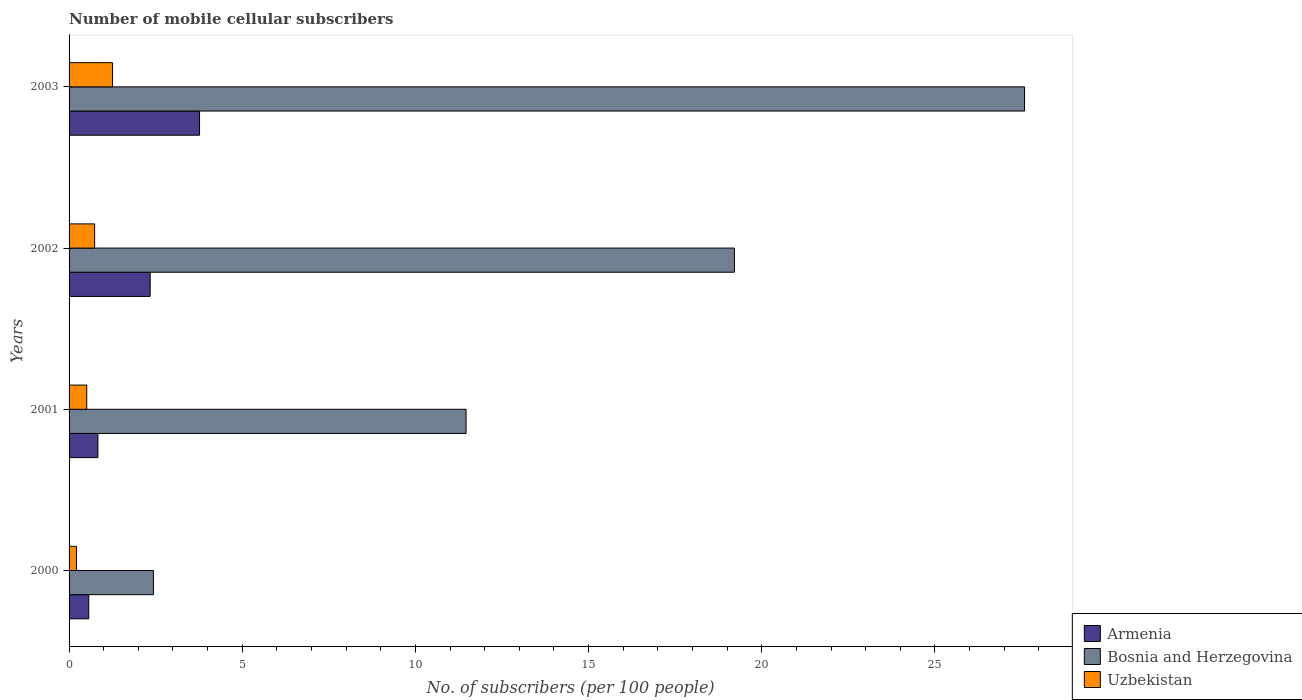How many different coloured bars are there?
Offer a terse response. 3. Are the number of bars per tick equal to the number of legend labels?
Provide a short and direct response. Yes. Are the number of bars on each tick of the Y-axis equal?
Your answer should be very brief. Yes. How many bars are there on the 3rd tick from the bottom?
Your answer should be compact. 3. In how many cases, is the number of bars for a given year not equal to the number of legend labels?
Make the answer very short. 0. What is the number of mobile cellular subscribers in Bosnia and Herzegovina in 2001?
Offer a terse response. 11.46. Across all years, what is the maximum number of mobile cellular subscribers in Bosnia and Herzegovina?
Provide a short and direct response. 27.59. Across all years, what is the minimum number of mobile cellular subscribers in Uzbekistan?
Offer a very short reply. 0.21. What is the total number of mobile cellular subscribers in Armenia in the graph?
Provide a succinct answer. 7.51. What is the difference between the number of mobile cellular subscribers in Uzbekistan in 2000 and that in 2003?
Offer a terse response. -1.04. What is the difference between the number of mobile cellular subscribers in Armenia in 2000 and the number of mobile cellular subscribers in Bosnia and Herzegovina in 2002?
Your answer should be compact. -18.64. What is the average number of mobile cellular subscribers in Uzbekistan per year?
Offer a terse response. 0.68. In the year 2001, what is the difference between the number of mobile cellular subscribers in Uzbekistan and number of mobile cellular subscribers in Bosnia and Herzegovina?
Offer a very short reply. -10.95. What is the ratio of the number of mobile cellular subscribers in Bosnia and Herzegovina in 2000 to that in 2003?
Ensure brevity in your answer.  0.09. Is the difference between the number of mobile cellular subscribers in Uzbekistan in 2000 and 2001 greater than the difference between the number of mobile cellular subscribers in Bosnia and Herzegovina in 2000 and 2001?
Keep it short and to the point. Yes. What is the difference between the highest and the second highest number of mobile cellular subscribers in Uzbekistan?
Offer a very short reply. 0.52. What is the difference between the highest and the lowest number of mobile cellular subscribers in Armenia?
Provide a short and direct response. 3.2. In how many years, is the number of mobile cellular subscribers in Armenia greater than the average number of mobile cellular subscribers in Armenia taken over all years?
Your response must be concise. 2. Is the sum of the number of mobile cellular subscribers in Uzbekistan in 2002 and 2003 greater than the maximum number of mobile cellular subscribers in Bosnia and Herzegovina across all years?
Offer a very short reply. No. What does the 1st bar from the top in 2000 represents?
Make the answer very short. Uzbekistan. What does the 1st bar from the bottom in 2003 represents?
Give a very brief answer. Armenia. What is the difference between two consecutive major ticks on the X-axis?
Make the answer very short. 5. Are the values on the major ticks of X-axis written in scientific E-notation?
Give a very brief answer. No. Does the graph contain any zero values?
Your response must be concise. No. How are the legend labels stacked?
Offer a terse response. Vertical. What is the title of the graph?
Provide a succinct answer. Number of mobile cellular subscribers. What is the label or title of the X-axis?
Offer a terse response. No. of subscribers (per 100 people). What is the label or title of the Y-axis?
Give a very brief answer. Years. What is the No. of subscribers (per 100 people) in Armenia in 2000?
Your answer should be very brief. 0.57. What is the No. of subscribers (per 100 people) in Bosnia and Herzegovina in 2000?
Offer a terse response. 2.44. What is the No. of subscribers (per 100 people) in Uzbekistan in 2000?
Your answer should be compact. 0.21. What is the No. of subscribers (per 100 people) in Armenia in 2001?
Ensure brevity in your answer.  0.83. What is the No. of subscribers (per 100 people) in Bosnia and Herzegovina in 2001?
Your answer should be compact. 11.46. What is the No. of subscribers (per 100 people) of Uzbekistan in 2001?
Give a very brief answer. 0.51. What is the No. of subscribers (per 100 people) in Armenia in 2002?
Ensure brevity in your answer.  2.34. What is the No. of subscribers (per 100 people) in Bosnia and Herzegovina in 2002?
Give a very brief answer. 19.21. What is the No. of subscribers (per 100 people) of Uzbekistan in 2002?
Give a very brief answer. 0.74. What is the No. of subscribers (per 100 people) in Armenia in 2003?
Your answer should be compact. 3.77. What is the No. of subscribers (per 100 people) of Bosnia and Herzegovina in 2003?
Ensure brevity in your answer.  27.59. What is the No. of subscribers (per 100 people) in Uzbekistan in 2003?
Provide a succinct answer. 1.26. Across all years, what is the maximum No. of subscribers (per 100 people) in Armenia?
Keep it short and to the point. 3.77. Across all years, what is the maximum No. of subscribers (per 100 people) in Bosnia and Herzegovina?
Keep it short and to the point. 27.59. Across all years, what is the maximum No. of subscribers (per 100 people) in Uzbekistan?
Ensure brevity in your answer.  1.26. Across all years, what is the minimum No. of subscribers (per 100 people) of Armenia?
Offer a very short reply. 0.57. Across all years, what is the minimum No. of subscribers (per 100 people) in Bosnia and Herzegovina?
Provide a succinct answer. 2.44. Across all years, what is the minimum No. of subscribers (per 100 people) of Uzbekistan?
Your response must be concise. 0.21. What is the total No. of subscribers (per 100 people) of Armenia in the graph?
Offer a terse response. 7.51. What is the total No. of subscribers (per 100 people) of Bosnia and Herzegovina in the graph?
Make the answer very short. 60.7. What is the total No. of subscribers (per 100 people) of Uzbekistan in the graph?
Make the answer very short. 2.72. What is the difference between the No. of subscribers (per 100 people) of Armenia in 2000 and that in 2001?
Give a very brief answer. -0.27. What is the difference between the No. of subscribers (per 100 people) of Bosnia and Herzegovina in 2000 and that in 2001?
Your answer should be compact. -9.03. What is the difference between the No. of subscribers (per 100 people) of Uzbekistan in 2000 and that in 2001?
Provide a short and direct response. -0.3. What is the difference between the No. of subscribers (per 100 people) of Armenia in 2000 and that in 2002?
Offer a terse response. -1.77. What is the difference between the No. of subscribers (per 100 people) of Bosnia and Herzegovina in 2000 and that in 2002?
Offer a terse response. -16.78. What is the difference between the No. of subscribers (per 100 people) of Uzbekistan in 2000 and that in 2002?
Keep it short and to the point. -0.52. What is the difference between the No. of subscribers (per 100 people) in Armenia in 2000 and that in 2003?
Your answer should be compact. -3.2. What is the difference between the No. of subscribers (per 100 people) of Bosnia and Herzegovina in 2000 and that in 2003?
Offer a terse response. -25.15. What is the difference between the No. of subscribers (per 100 people) in Uzbekistan in 2000 and that in 2003?
Your response must be concise. -1.04. What is the difference between the No. of subscribers (per 100 people) in Armenia in 2001 and that in 2002?
Your answer should be very brief. -1.51. What is the difference between the No. of subscribers (per 100 people) of Bosnia and Herzegovina in 2001 and that in 2002?
Offer a very short reply. -7.75. What is the difference between the No. of subscribers (per 100 people) of Uzbekistan in 2001 and that in 2002?
Keep it short and to the point. -0.23. What is the difference between the No. of subscribers (per 100 people) in Armenia in 2001 and that in 2003?
Your response must be concise. -2.93. What is the difference between the No. of subscribers (per 100 people) of Bosnia and Herzegovina in 2001 and that in 2003?
Ensure brevity in your answer.  -16.12. What is the difference between the No. of subscribers (per 100 people) of Uzbekistan in 2001 and that in 2003?
Ensure brevity in your answer.  -0.75. What is the difference between the No. of subscribers (per 100 people) of Armenia in 2002 and that in 2003?
Your response must be concise. -1.43. What is the difference between the No. of subscribers (per 100 people) of Bosnia and Herzegovina in 2002 and that in 2003?
Your answer should be very brief. -8.38. What is the difference between the No. of subscribers (per 100 people) of Uzbekistan in 2002 and that in 2003?
Give a very brief answer. -0.52. What is the difference between the No. of subscribers (per 100 people) of Armenia in 2000 and the No. of subscribers (per 100 people) of Bosnia and Herzegovina in 2001?
Offer a very short reply. -10.9. What is the difference between the No. of subscribers (per 100 people) in Armenia in 2000 and the No. of subscribers (per 100 people) in Uzbekistan in 2001?
Your answer should be compact. 0.06. What is the difference between the No. of subscribers (per 100 people) in Bosnia and Herzegovina in 2000 and the No. of subscribers (per 100 people) in Uzbekistan in 2001?
Provide a short and direct response. 1.93. What is the difference between the No. of subscribers (per 100 people) in Armenia in 2000 and the No. of subscribers (per 100 people) in Bosnia and Herzegovina in 2002?
Provide a short and direct response. -18.64. What is the difference between the No. of subscribers (per 100 people) in Armenia in 2000 and the No. of subscribers (per 100 people) in Uzbekistan in 2002?
Give a very brief answer. -0.17. What is the difference between the No. of subscribers (per 100 people) of Bosnia and Herzegovina in 2000 and the No. of subscribers (per 100 people) of Uzbekistan in 2002?
Your answer should be compact. 1.7. What is the difference between the No. of subscribers (per 100 people) of Armenia in 2000 and the No. of subscribers (per 100 people) of Bosnia and Herzegovina in 2003?
Your answer should be very brief. -27.02. What is the difference between the No. of subscribers (per 100 people) of Armenia in 2000 and the No. of subscribers (per 100 people) of Uzbekistan in 2003?
Your answer should be very brief. -0.69. What is the difference between the No. of subscribers (per 100 people) in Bosnia and Herzegovina in 2000 and the No. of subscribers (per 100 people) in Uzbekistan in 2003?
Provide a succinct answer. 1.18. What is the difference between the No. of subscribers (per 100 people) in Armenia in 2001 and the No. of subscribers (per 100 people) in Bosnia and Herzegovina in 2002?
Keep it short and to the point. -18.38. What is the difference between the No. of subscribers (per 100 people) of Armenia in 2001 and the No. of subscribers (per 100 people) of Uzbekistan in 2002?
Offer a very short reply. 0.1. What is the difference between the No. of subscribers (per 100 people) of Bosnia and Herzegovina in 2001 and the No. of subscribers (per 100 people) of Uzbekistan in 2002?
Provide a succinct answer. 10.73. What is the difference between the No. of subscribers (per 100 people) in Armenia in 2001 and the No. of subscribers (per 100 people) in Bosnia and Herzegovina in 2003?
Give a very brief answer. -26.76. What is the difference between the No. of subscribers (per 100 people) in Armenia in 2001 and the No. of subscribers (per 100 people) in Uzbekistan in 2003?
Keep it short and to the point. -0.42. What is the difference between the No. of subscribers (per 100 people) of Bosnia and Herzegovina in 2001 and the No. of subscribers (per 100 people) of Uzbekistan in 2003?
Ensure brevity in your answer.  10.21. What is the difference between the No. of subscribers (per 100 people) of Armenia in 2002 and the No. of subscribers (per 100 people) of Bosnia and Herzegovina in 2003?
Ensure brevity in your answer.  -25.25. What is the difference between the No. of subscribers (per 100 people) in Armenia in 2002 and the No. of subscribers (per 100 people) in Uzbekistan in 2003?
Your response must be concise. 1.09. What is the difference between the No. of subscribers (per 100 people) of Bosnia and Herzegovina in 2002 and the No. of subscribers (per 100 people) of Uzbekistan in 2003?
Your answer should be compact. 17.96. What is the average No. of subscribers (per 100 people) in Armenia per year?
Your answer should be compact. 1.88. What is the average No. of subscribers (per 100 people) of Bosnia and Herzegovina per year?
Your answer should be very brief. 15.17. What is the average No. of subscribers (per 100 people) in Uzbekistan per year?
Offer a terse response. 0.68. In the year 2000, what is the difference between the No. of subscribers (per 100 people) of Armenia and No. of subscribers (per 100 people) of Bosnia and Herzegovina?
Ensure brevity in your answer.  -1.87. In the year 2000, what is the difference between the No. of subscribers (per 100 people) in Armenia and No. of subscribers (per 100 people) in Uzbekistan?
Ensure brevity in your answer.  0.35. In the year 2000, what is the difference between the No. of subscribers (per 100 people) in Bosnia and Herzegovina and No. of subscribers (per 100 people) in Uzbekistan?
Your answer should be very brief. 2.22. In the year 2001, what is the difference between the No. of subscribers (per 100 people) of Armenia and No. of subscribers (per 100 people) of Bosnia and Herzegovina?
Give a very brief answer. -10.63. In the year 2001, what is the difference between the No. of subscribers (per 100 people) in Armenia and No. of subscribers (per 100 people) in Uzbekistan?
Offer a very short reply. 0.32. In the year 2001, what is the difference between the No. of subscribers (per 100 people) in Bosnia and Herzegovina and No. of subscribers (per 100 people) in Uzbekistan?
Your answer should be compact. 10.95. In the year 2002, what is the difference between the No. of subscribers (per 100 people) in Armenia and No. of subscribers (per 100 people) in Bosnia and Herzegovina?
Make the answer very short. -16.87. In the year 2002, what is the difference between the No. of subscribers (per 100 people) of Armenia and No. of subscribers (per 100 people) of Uzbekistan?
Offer a very short reply. 1.6. In the year 2002, what is the difference between the No. of subscribers (per 100 people) in Bosnia and Herzegovina and No. of subscribers (per 100 people) in Uzbekistan?
Offer a very short reply. 18.47. In the year 2003, what is the difference between the No. of subscribers (per 100 people) of Armenia and No. of subscribers (per 100 people) of Bosnia and Herzegovina?
Offer a terse response. -23.82. In the year 2003, what is the difference between the No. of subscribers (per 100 people) in Armenia and No. of subscribers (per 100 people) in Uzbekistan?
Give a very brief answer. 2.51. In the year 2003, what is the difference between the No. of subscribers (per 100 people) of Bosnia and Herzegovina and No. of subscribers (per 100 people) of Uzbekistan?
Keep it short and to the point. 26.33. What is the ratio of the No. of subscribers (per 100 people) in Armenia in 2000 to that in 2001?
Offer a very short reply. 0.68. What is the ratio of the No. of subscribers (per 100 people) of Bosnia and Herzegovina in 2000 to that in 2001?
Ensure brevity in your answer.  0.21. What is the ratio of the No. of subscribers (per 100 people) of Uzbekistan in 2000 to that in 2001?
Offer a very short reply. 0.42. What is the ratio of the No. of subscribers (per 100 people) in Armenia in 2000 to that in 2002?
Ensure brevity in your answer.  0.24. What is the ratio of the No. of subscribers (per 100 people) of Bosnia and Herzegovina in 2000 to that in 2002?
Provide a succinct answer. 0.13. What is the ratio of the No. of subscribers (per 100 people) of Uzbekistan in 2000 to that in 2002?
Give a very brief answer. 0.29. What is the ratio of the No. of subscribers (per 100 people) in Armenia in 2000 to that in 2003?
Your answer should be very brief. 0.15. What is the ratio of the No. of subscribers (per 100 people) of Bosnia and Herzegovina in 2000 to that in 2003?
Offer a terse response. 0.09. What is the ratio of the No. of subscribers (per 100 people) in Uzbekistan in 2000 to that in 2003?
Make the answer very short. 0.17. What is the ratio of the No. of subscribers (per 100 people) of Armenia in 2001 to that in 2002?
Give a very brief answer. 0.36. What is the ratio of the No. of subscribers (per 100 people) of Bosnia and Herzegovina in 2001 to that in 2002?
Make the answer very short. 0.6. What is the ratio of the No. of subscribers (per 100 people) in Uzbekistan in 2001 to that in 2002?
Provide a succinct answer. 0.69. What is the ratio of the No. of subscribers (per 100 people) in Armenia in 2001 to that in 2003?
Your response must be concise. 0.22. What is the ratio of the No. of subscribers (per 100 people) of Bosnia and Herzegovina in 2001 to that in 2003?
Provide a short and direct response. 0.42. What is the ratio of the No. of subscribers (per 100 people) in Uzbekistan in 2001 to that in 2003?
Your answer should be very brief. 0.41. What is the ratio of the No. of subscribers (per 100 people) of Armenia in 2002 to that in 2003?
Provide a succinct answer. 0.62. What is the ratio of the No. of subscribers (per 100 people) in Bosnia and Herzegovina in 2002 to that in 2003?
Your answer should be compact. 0.7. What is the ratio of the No. of subscribers (per 100 people) in Uzbekistan in 2002 to that in 2003?
Provide a short and direct response. 0.59. What is the difference between the highest and the second highest No. of subscribers (per 100 people) in Armenia?
Keep it short and to the point. 1.43. What is the difference between the highest and the second highest No. of subscribers (per 100 people) of Bosnia and Herzegovina?
Ensure brevity in your answer.  8.38. What is the difference between the highest and the second highest No. of subscribers (per 100 people) in Uzbekistan?
Provide a succinct answer. 0.52. What is the difference between the highest and the lowest No. of subscribers (per 100 people) of Armenia?
Provide a short and direct response. 3.2. What is the difference between the highest and the lowest No. of subscribers (per 100 people) of Bosnia and Herzegovina?
Your answer should be very brief. 25.15. What is the difference between the highest and the lowest No. of subscribers (per 100 people) of Uzbekistan?
Keep it short and to the point. 1.04. 